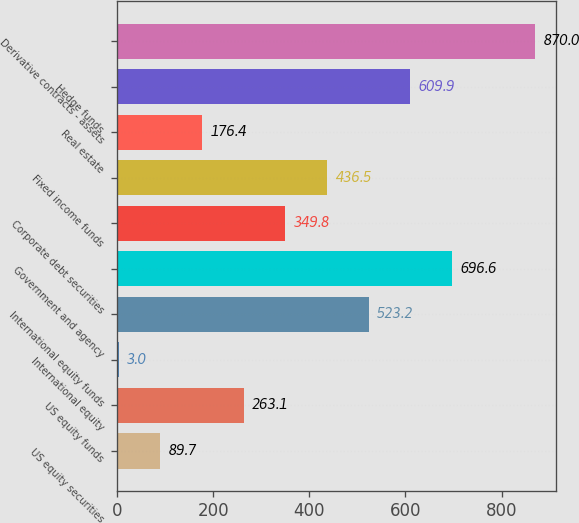Convert chart. <chart><loc_0><loc_0><loc_500><loc_500><bar_chart><fcel>US equity securities<fcel>US equity funds<fcel>International equity<fcel>International equity funds<fcel>Government and agency<fcel>Corporate debt securities<fcel>Fixed income funds<fcel>Real estate<fcel>Hedge funds<fcel>Derivative contracts - assets<nl><fcel>89.7<fcel>263.1<fcel>3<fcel>523.2<fcel>696.6<fcel>349.8<fcel>436.5<fcel>176.4<fcel>609.9<fcel>870<nl></chart> 